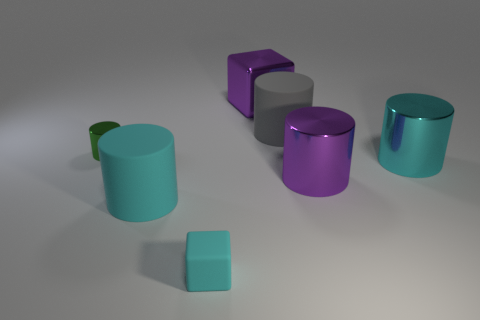Subtract all tiny cylinders. How many cylinders are left? 4 Add 2 gray cylinders. How many objects exist? 9 Subtract all purple cylinders. How many cylinders are left? 4 Subtract all cubes. How many objects are left? 5 Subtract all brown balls. How many green cylinders are left? 1 Subtract 0 purple balls. How many objects are left? 7 Subtract 3 cylinders. How many cylinders are left? 2 Subtract all purple cubes. Subtract all green cylinders. How many cubes are left? 1 Subtract all cyan matte blocks. Subtract all cylinders. How many objects are left? 1 Add 2 tiny green shiny cylinders. How many tiny green shiny cylinders are left? 3 